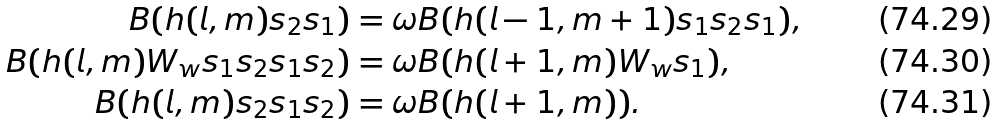<formula> <loc_0><loc_0><loc_500><loc_500>B ( h ( l , m ) s _ { 2 } s _ { 1 } ) & = \omega B ( h ( l - 1 , m + 1 ) s _ { 1 } s _ { 2 } s _ { 1 } ) , \\ B ( h ( l , m ) W _ { w } s _ { 1 } s _ { 2 } s _ { 1 } s _ { 2 } ) & = \omega B ( h ( l + 1 , m ) W _ { w } s _ { 1 } ) , \\ B ( h ( l , m ) s _ { 2 } s _ { 1 } s _ { 2 } ) & = \omega B ( h ( l + 1 , m ) ) .</formula> 